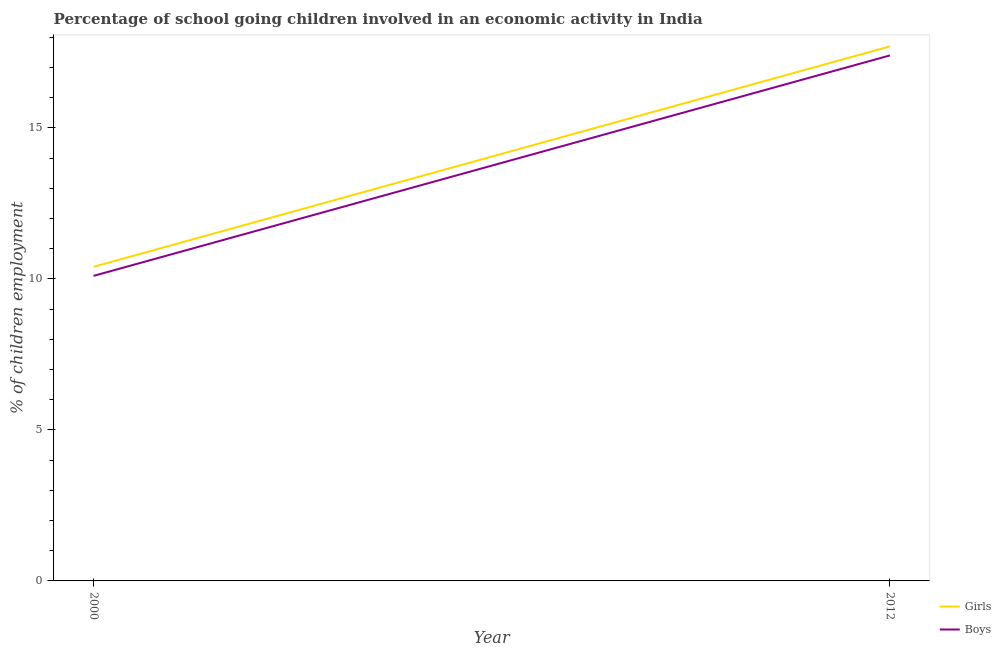Does the line corresponding to percentage of school going boys intersect with the line corresponding to percentage of school going girls?
Ensure brevity in your answer.  No. In which year was the percentage of school going boys maximum?
Your response must be concise. 2012. In which year was the percentage of school going girls minimum?
Provide a succinct answer. 2000. What is the total percentage of school going girls in the graph?
Provide a short and direct response. 28.1. What is the difference between the percentage of school going boys in 2000 and that in 2012?
Offer a very short reply. -7.3. What is the difference between the percentage of school going boys in 2012 and the percentage of school going girls in 2000?
Your response must be concise. 7. What is the average percentage of school going girls per year?
Keep it short and to the point. 14.05. In the year 2012, what is the difference between the percentage of school going boys and percentage of school going girls?
Your answer should be compact. -0.3. In how many years, is the percentage of school going boys greater than 14 %?
Make the answer very short. 1. What is the ratio of the percentage of school going girls in 2000 to that in 2012?
Keep it short and to the point. 0.59. Is the percentage of school going girls strictly greater than the percentage of school going boys over the years?
Provide a short and direct response. Yes. Does the graph contain any zero values?
Offer a terse response. No. How many legend labels are there?
Your answer should be very brief. 2. What is the title of the graph?
Ensure brevity in your answer.  Percentage of school going children involved in an economic activity in India. Does "GDP at market prices" appear as one of the legend labels in the graph?
Provide a succinct answer. No. What is the label or title of the Y-axis?
Keep it short and to the point. % of children employment. What is the % of children employment in Girls in 2000?
Make the answer very short. 10.4. What is the % of children employment of Boys in 2000?
Offer a very short reply. 10.1. What is the % of children employment of Girls in 2012?
Provide a short and direct response. 17.7. What is the % of children employment of Boys in 2012?
Provide a short and direct response. 17.4. Across all years, what is the maximum % of children employment in Girls?
Ensure brevity in your answer.  17.7. Across all years, what is the minimum % of children employment of Girls?
Offer a very short reply. 10.4. What is the total % of children employment of Girls in the graph?
Provide a short and direct response. 28.1. What is the difference between the % of children employment in Girls in 2000 and that in 2012?
Offer a terse response. -7.3. What is the difference between the % of children employment in Boys in 2000 and that in 2012?
Provide a succinct answer. -7.3. What is the average % of children employment in Girls per year?
Provide a short and direct response. 14.05. What is the average % of children employment in Boys per year?
Provide a succinct answer. 13.75. What is the ratio of the % of children employment in Girls in 2000 to that in 2012?
Your response must be concise. 0.59. What is the ratio of the % of children employment of Boys in 2000 to that in 2012?
Provide a short and direct response. 0.58. 